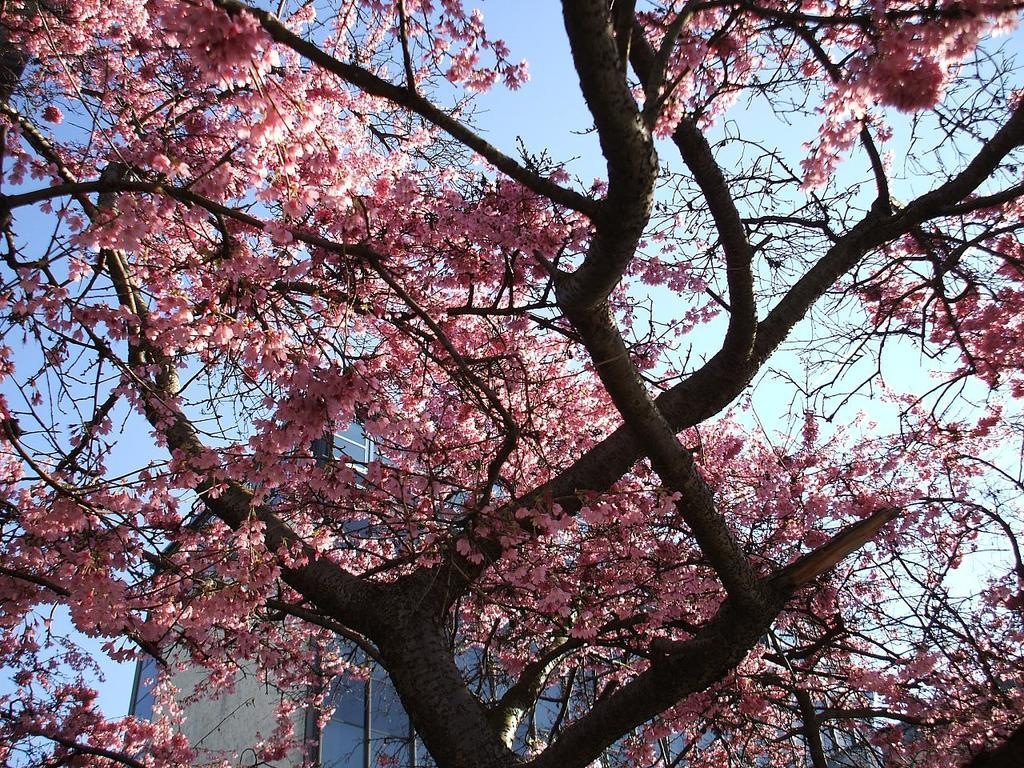What type of vegetation is present in the image? There are trees with flowers in the image. What can be seen in the background of the image? There is a building and the sky visible in the background of the image. What type of tool is being used to tighten the screw in the image? There is no screw or tool present in the image; it features trees with flowers and a building in the background. 